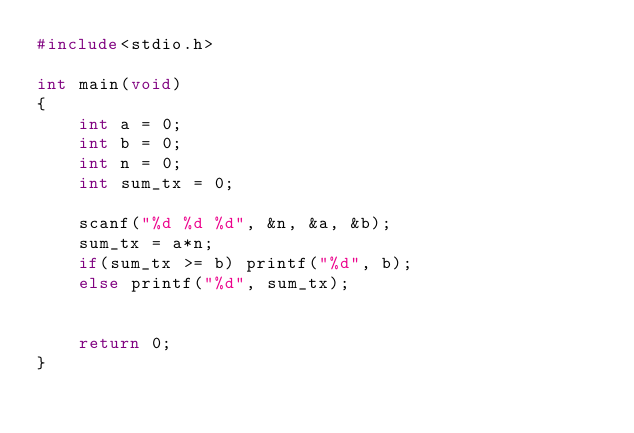Convert code to text. <code><loc_0><loc_0><loc_500><loc_500><_C_>#include<stdio.h>

int main(void)
{
    int a = 0;
    int b = 0;
    int n = 0;
    int sum_tx = 0;

    scanf("%d %d %d", &n, &a, &b);
    sum_tx = a*n;
    if(sum_tx >= b) printf("%d", b);
    else printf("%d", sum_tx);


    return 0;
}
</code> 